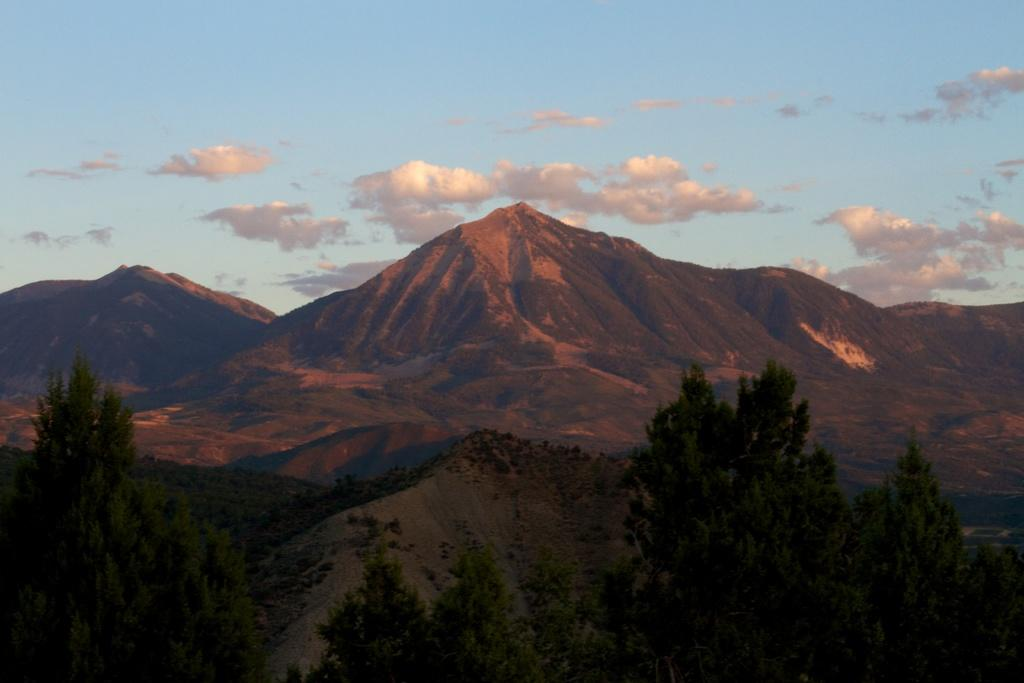What type of natural features can be seen in the image? There are trees and mountains in the image. What part of the natural environment is visible in the image? The sky is visible in the image. What type of business is being conducted in the image? There is no indication of any business activity in the image; it primarily features natural elements such as trees, mountains, and the sky. 